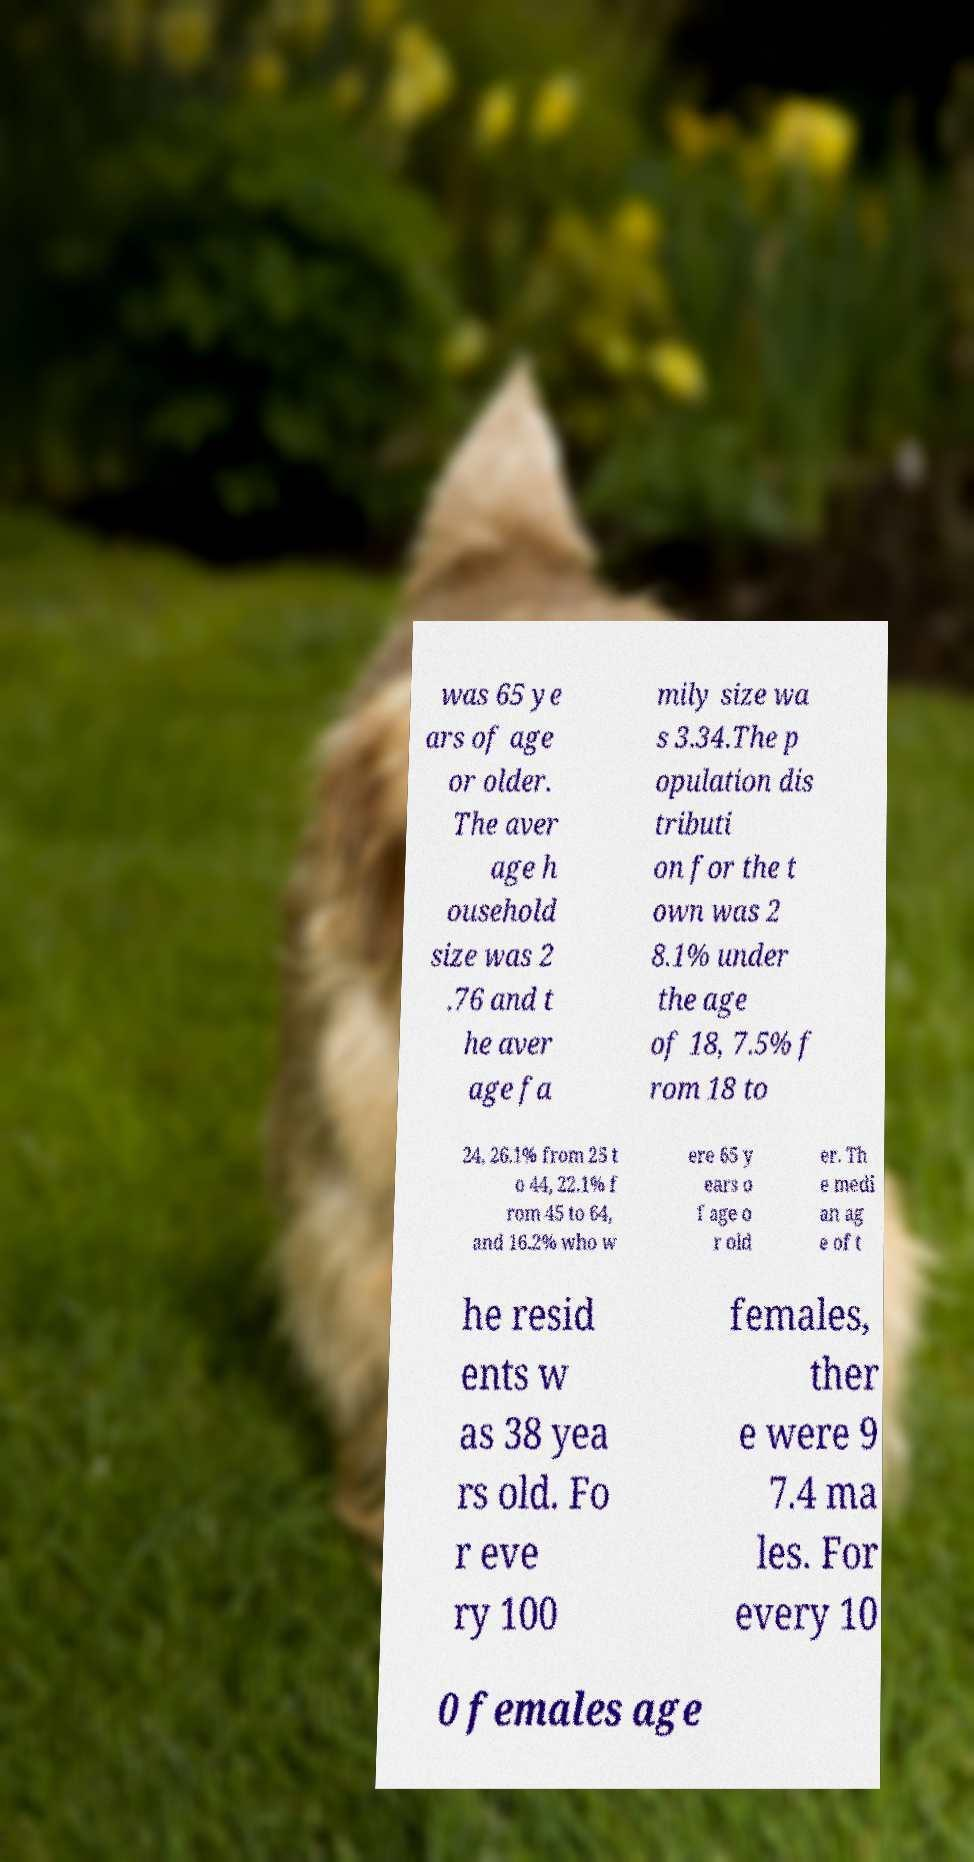What messages or text are displayed in this image? I need them in a readable, typed format. was 65 ye ars of age or older. The aver age h ousehold size was 2 .76 and t he aver age fa mily size wa s 3.34.The p opulation dis tributi on for the t own was 2 8.1% under the age of 18, 7.5% f rom 18 to 24, 26.1% from 25 t o 44, 22.1% f rom 45 to 64, and 16.2% who w ere 65 y ears o f age o r old er. Th e medi an ag e of t he resid ents w as 38 yea rs old. Fo r eve ry 100 females, ther e were 9 7.4 ma les. For every 10 0 females age 